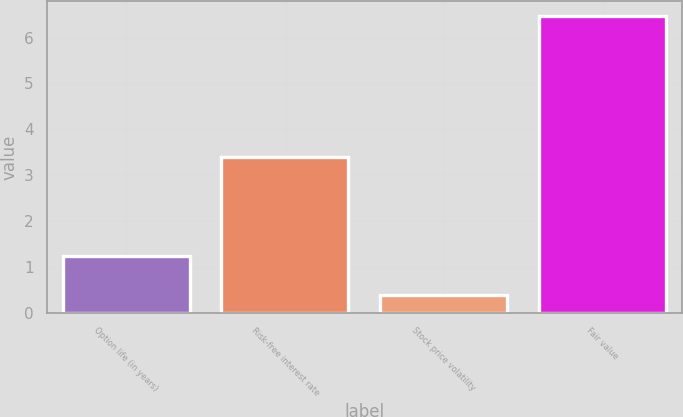<chart> <loc_0><loc_0><loc_500><loc_500><bar_chart><fcel>Option life (in years)<fcel>Risk-free interest rate<fcel>Stock price volatility<fcel>Fair value<nl><fcel>1.24<fcel>3.4<fcel>0.38<fcel>6.47<nl></chart> 